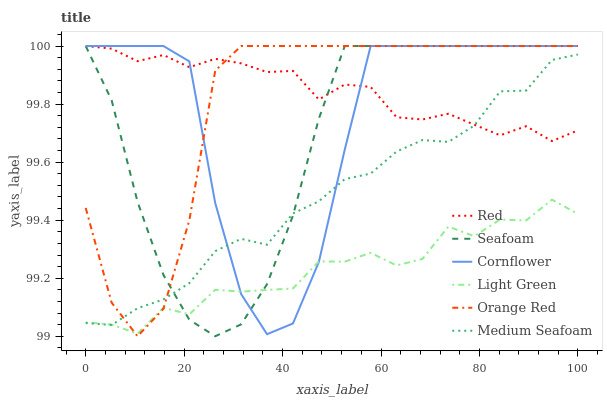Does Light Green have the minimum area under the curve?
Answer yes or no. Yes. Does Red have the maximum area under the curve?
Answer yes or no. Yes. Does Seafoam have the minimum area under the curve?
Answer yes or no. No. Does Seafoam have the maximum area under the curve?
Answer yes or no. No. Is Red the smoothest?
Answer yes or no. Yes. Is Cornflower the roughest?
Answer yes or no. Yes. Is Seafoam the smoothest?
Answer yes or no. No. Is Seafoam the roughest?
Answer yes or no. No. Does Orange Red have the lowest value?
Answer yes or no. Yes. Does Seafoam have the lowest value?
Answer yes or no. No. Does Red have the highest value?
Answer yes or no. Yes. Does Light Green have the highest value?
Answer yes or no. No. Is Light Green less than Red?
Answer yes or no. Yes. Is Red greater than Light Green?
Answer yes or no. Yes. Does Seafoam intersect Medium Seafoam?
Answer yes or no. Yes. Is Seafoam less than Medium Seafoam?
Answer yes or no. No. Is Seafoam greater than Medium Seafoam?
Answer yes or no. No. Does Light Green intersect Red?
Answer yes or no. No. 